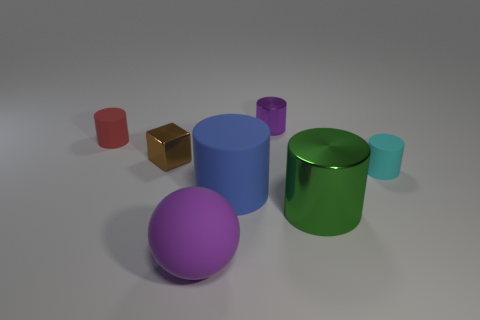Is the color of the big rubber sphere the same as the tiny metal cylinder?
Keep it short and to the point. Yes. What is the shape of the tiny thing that is the same color as the big rubber ball?
Your answer should be compact. Cylinder. Is the number of small metallic blocks greater than the number of big gray balls?
Provide a short and direct response. Yes. There is a cylinder behind the red cylinder; what is its color?
Offer a very short reply. Purple. Is the shape of the red matte thing the same as the cyan object?
Provide a succinct answer. Yes. There is a metal thing that is both on the right side of the large blue matte thing and behind the cyan matte cylinder; what is its color?
Keep it short and to the point. Purple. There is a matte cylinder behind the small shiny cube; is it the same size as the purple thing that is in front of the cyan rubber thing?
Offer a terse response. No. How many objects are either small rubber objects left of the green thing or big blue matte cylinders?
Offer a very short reply. 2. What is the material of the tiny red object?
Your answer should be very brief. Rubber. Is the purple matte ball the same size as the cyan rubber object?
Offer a terse response. No. 